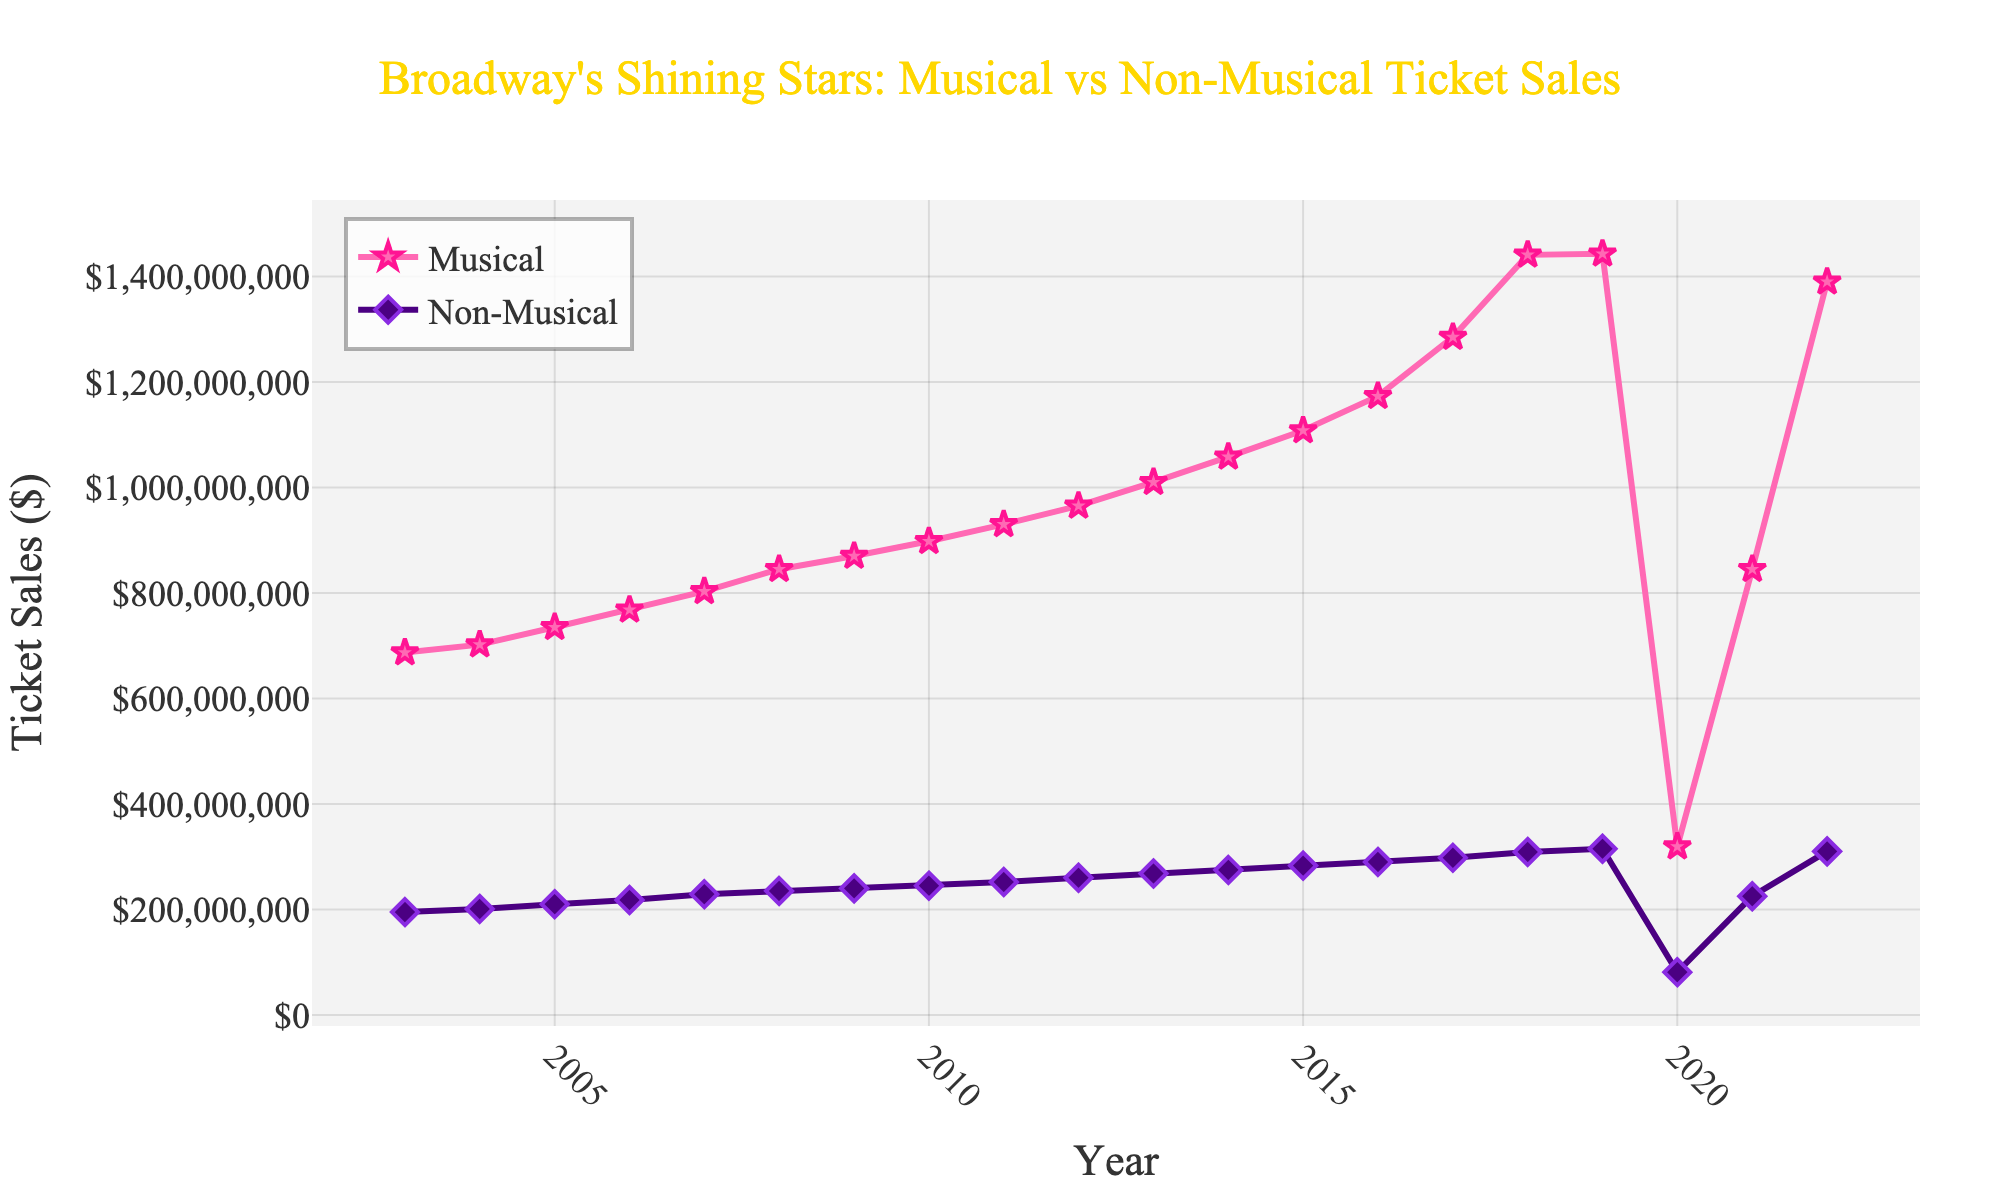What's the trend in musical ticket sales from 2003 to 2022? To determine the trend, observe how the musical ticket sales data changes over the years. The sales generally increase from 2003 to 2019, drop significantly in 2020, and then recover again in 2021-2022.
Answer: Increasing with a significant drop in 2020 Which year had the highest musical ticket sales? By looking at the highest point in the musical ticket sales line, it is clear that the peak occurs in 2022.
Answer: 2022 How did non-musical ticket sales change between 2019 and 2020? Compare the non-musical ticket sales in 2019 and 2020. There is a notable decrease from $315,000,000 in 2019 to $81,000,000 in 2020.
Answer: Decreased What is the difference in ticket sales between musicals and non-musicals in 2022? Subtract the non-musical ticket sales from the musical ticket sales for the year 2022: $1,390,000,000 (musicals) - $310,000,000 (non-musicals).
Answer: $1,080,000,000 Which show type recovered faster after the drop in 2020, musicals or non-musicals? Identify the recovery by comparing the 2020 and 2021 data. Musical ticket sales rose from $319,000,000 to $845,000,000, whereas non-musical ticket sales increased from $81,000,000 to $225,000,000. The musicals show a faster recovery.
Answer: Musicals Compare the musical ticket sales in 2003 and 2022. By how much did it increase? Subtract the musical ticket sales in 2003 from those in 2022: $1,390,000,000 (2022) - $687,000,000 (2003).
Answer: $703,000,000 During which year did non-musical shows experience the highest ticket sales growth compared to the previous year? Examine the differences between each consecutive year's non-musical ticket sales to find the greatest growth. The largest increase is between 2020 and 2021: $225,000,000 - $81,000,000.
Answer: 2021 What is the overall percentage increase in musical ticket sales from 2003 to 2019? First, calculate the initial and final sales for the period: $144,300,000 (2019) and $687,000,000 (2003). Use the formula: ((1443 - 687) / 687) * 100%. Replace sales in millions accordingly: ((1443 - 687) / 687) * 100 = 110%.
Answer: 110% What is the lowest ticket sales value for non-musical shows, and in what year did it occur? Find the lowest point on the non-musical ticket sales line and identify the corresponding year. The lowest value is $81,000,000 in 2020.
Answer: $81,000,000 in 2020 